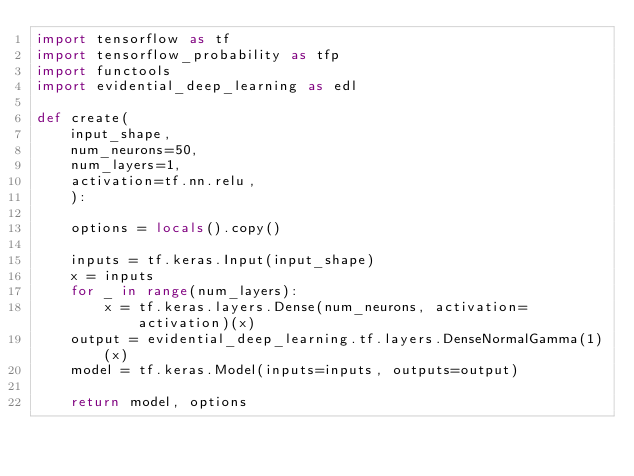<code> <loc_0><loc_0><loc_500><loc_500><_Python_>import tensorflow as tf
import tensorflow_probability as tfp
import functools
import evidential_deep_learning as edl

def create(
    input_shape,
    num_neurons=50,
    num_layers=1,
    activation=tf.nn.relu,
    ):

    options = locals().copy()

    inputs = tf.keras.Input(input_shape)
    x = inputs
    for _ in range(num_layers):
        x = tf.keras.layers.Dense(num_neurons, activation=activation)(x)
    output = evidential_deep_learning.tf.layers.DenseNormalGamma(1)(x)
    model = tf.keras.Model(inputs=inputs, outputs=output)

    return model, options
</code> 